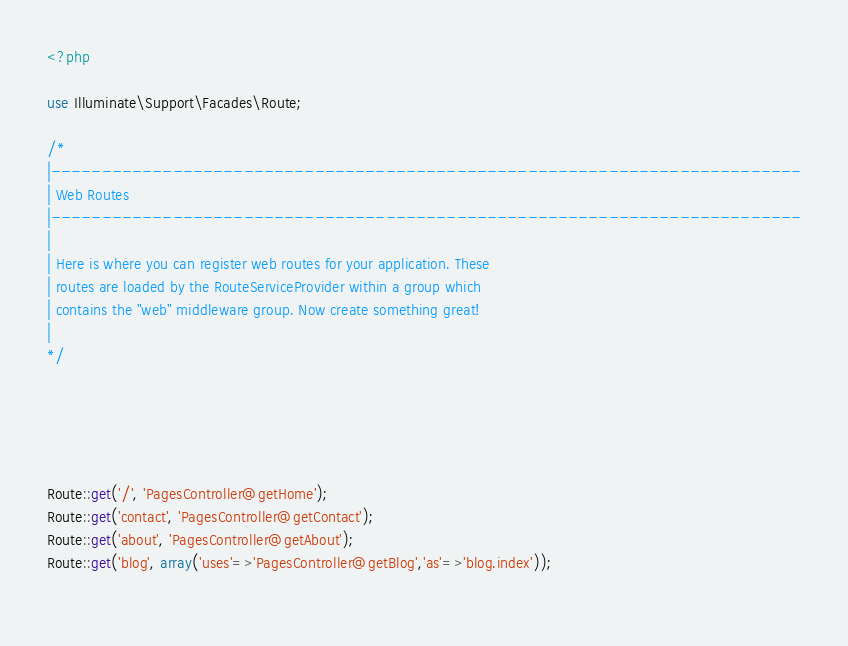<code> <loc_0><loc_0><loc_500><loc_500><_PHP_><?php

use Illuminate\Support\Facades\Route;

/*
|--------------------------------------------------------------------------
| Web Routes
|--------------------------------------------------------------------------
|
| Here is where you can register web routes for your application. These
| routes are loaded by the RouteServiceProvider within a group which
| contains the "web" middleware group. Now create something great!
|
*/





Route::get('/', 'PagesController@getHome');
Route::get('contact', 'PagesController@getContact');
Route::get('about', 'PagesController@getAbout');
Route::get('blog', array('uses'=>'PagesController@getBlog','as'=>'blog.index'));
   



</code> 